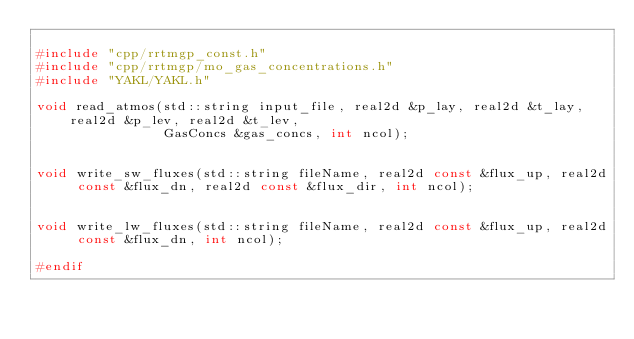Convert code to text. <code><loc_0><loc_0><loc_500><loc_500><_C_>
#include "cpp/rrtmgp_const.h"
#include "cpp/rrtmgp/mo_gas_concentrations.h"
#include "YAKL/YAKL.h"

void read_atmos(std::string input_file, real2d &p_lay, real2d &t_lay, real2d &p_lev, real2d &t_lev,
                GasConcs &gas_concs, int ncol);


void write_sw_fluxes(std::string fileName, real2d const &flux_up, real2d const &flux_dn, real2d const &flux_dir, int ncol);


void write_lw_fluxes(std::string fileName, real2d const &flux_up, real2d const &flux_dn, int ncol);

#endif
</code> 